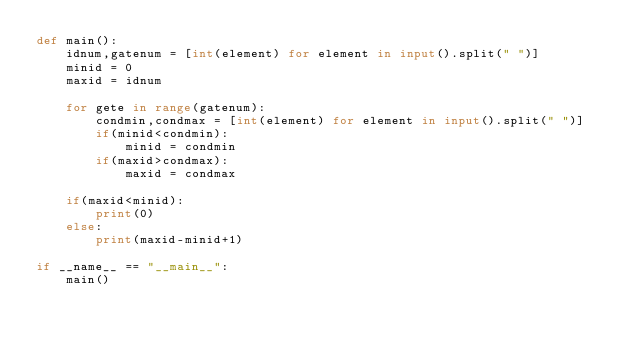<code> <loc_0><loc_0><loc_500><loc_500><_Python_>def main():
    idnum,gatenum = [int(element) for element in input().split(" ")]
    minid = 0
    maxid = idnum

    for gete in range(gatenum):
        condmin,condmax = [int(element) for element in input().split(" ")]
        if(minid<condmin):
            minid = condmin
        if(maxid>condmax):
            maxid = condmax

    if(maxid<minid):
        print(0)
    else:
        print(maxid-minid+1)

if __name__ == "__main__":
    main()</code> 